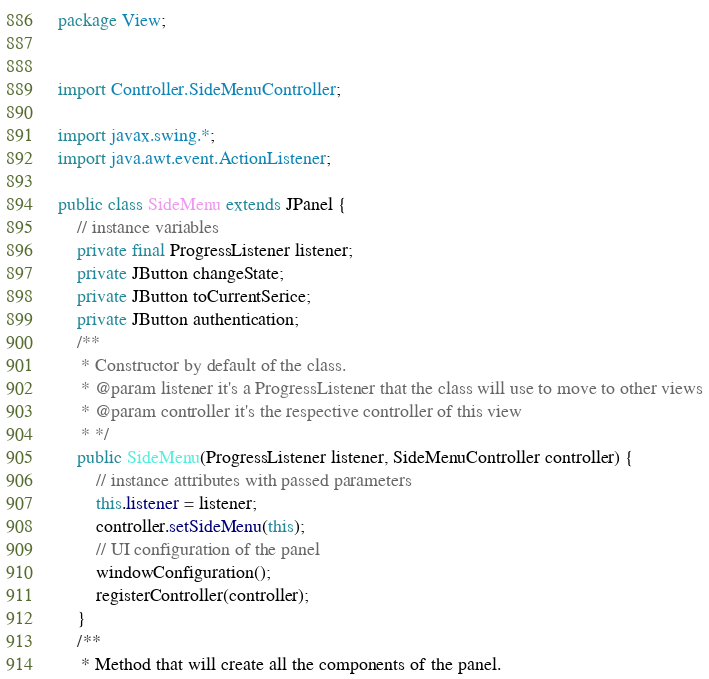Convert code to text. <code><loc_0><loc_0><loc_500><loc_500><_Java_>package View;


import Controller.SideMenuController;

import javax.swing.*;
import java.awt.event.ActionListener;

public class SideMenu extends JPanel {
    // instance variables
    private final ProgressListener listener;
    private JButton changeState;
    private JButton toCurrentSerice;
    private JButton authentication;
    /**
     * Constructor by default of the class.
     * @param listener it's a ProgressListener that the class will use to move to other views
     * @param controller it's the respective controller of this view
     * */
    public SideMenu(ProgressListener listener, SideMenuController controller) {
        // instance attributes with passed parameters
        this.listener = listener;
        controller.setSideMenu(this);
        // UI configuration of the panel
        windowConfiguration();
        registerController(controller);
    }
    /**
     * Method that will create all the components of the panel.</code> 